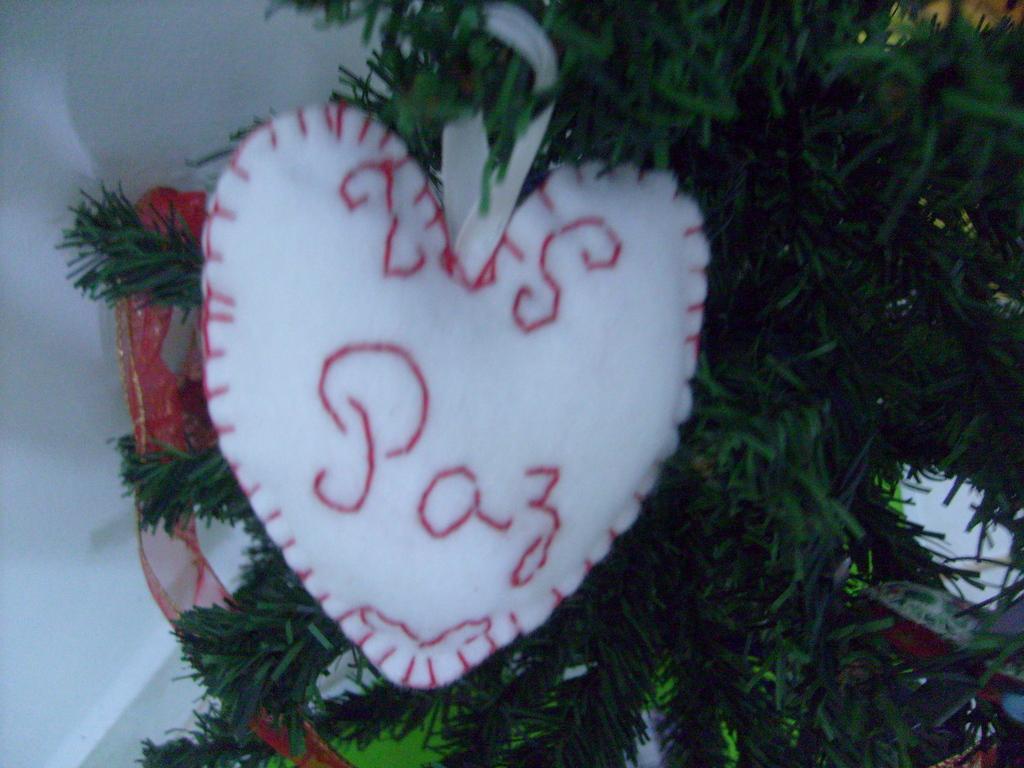Please provide a concise description of this image. As we can see in the image there is a wall, tree and heart shaped pillow. 